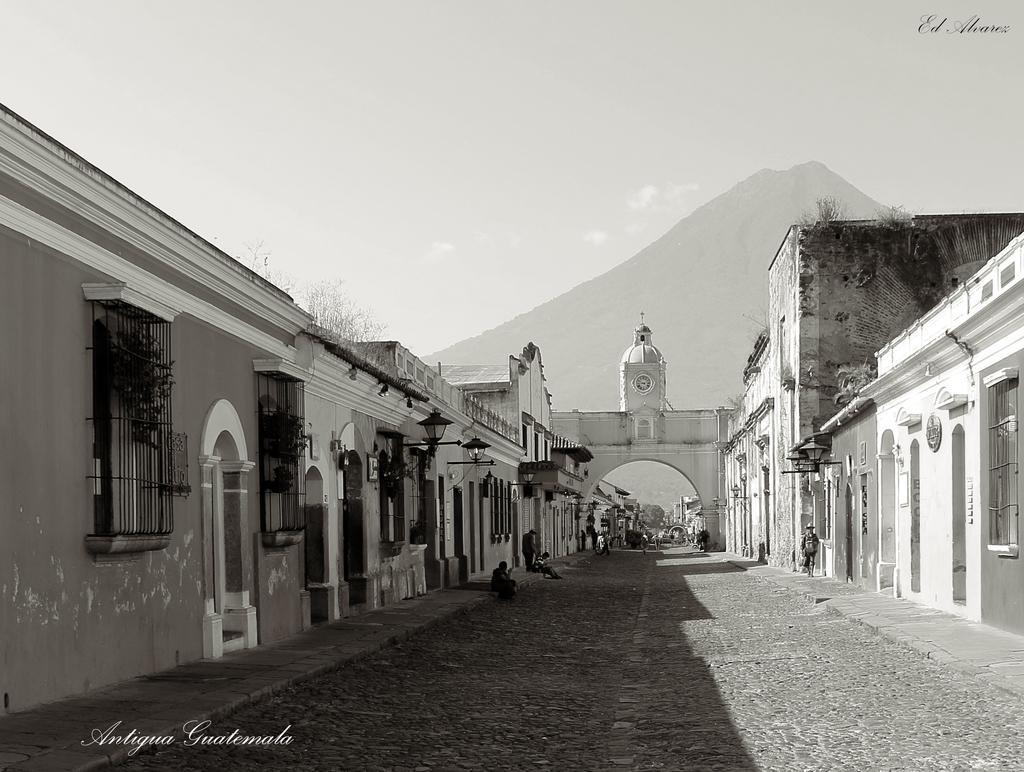How would you summarize this image in a sentence or two? It is the black and white image in which there is a path in the middle. There are buildings on either side of the path. In the background there is a hill. At the top there is the sky. On the footpath there are few people sitting on it. In the middle there is an arch. 